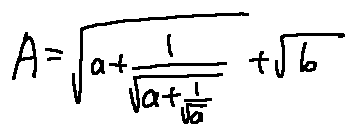Convert formula to latex. <formula><loc_0><loc_0><loc_500><loc_500>A = \sqrt { a + \frac { 1 } { \sqrt { a + \frac { 1 } { \sqrt { a } } } } } + \sqrt { b }</formula> 